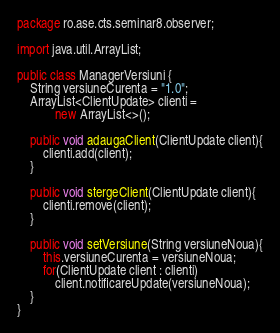<code> <loc_0><loc_0><loc_500><loc_500><_Java_>package ro.ase.cts.seminar8.observer;

import java.util.ArrayList;

public class ManagerVersiuni {
	String versiuneCurenta = "1.0";
	ArrayList<ClientUpdate> clienti = 
			new ArrayList<>();
	
	public void adaugaClient(ClientUpdate client){
		clienti.add(client);
	}
	
	public void stergeClient(ClientUpdate client){
		clienti.remove(client);
	}
	
	public void setVersiune(String versiuneNoua){
		this.versiuneCurenta = versiuneNoua;
		for(ClientUpdate client : clienti)
			client.notificareUpdate(versiuneNoua);
	}
}
</code> 